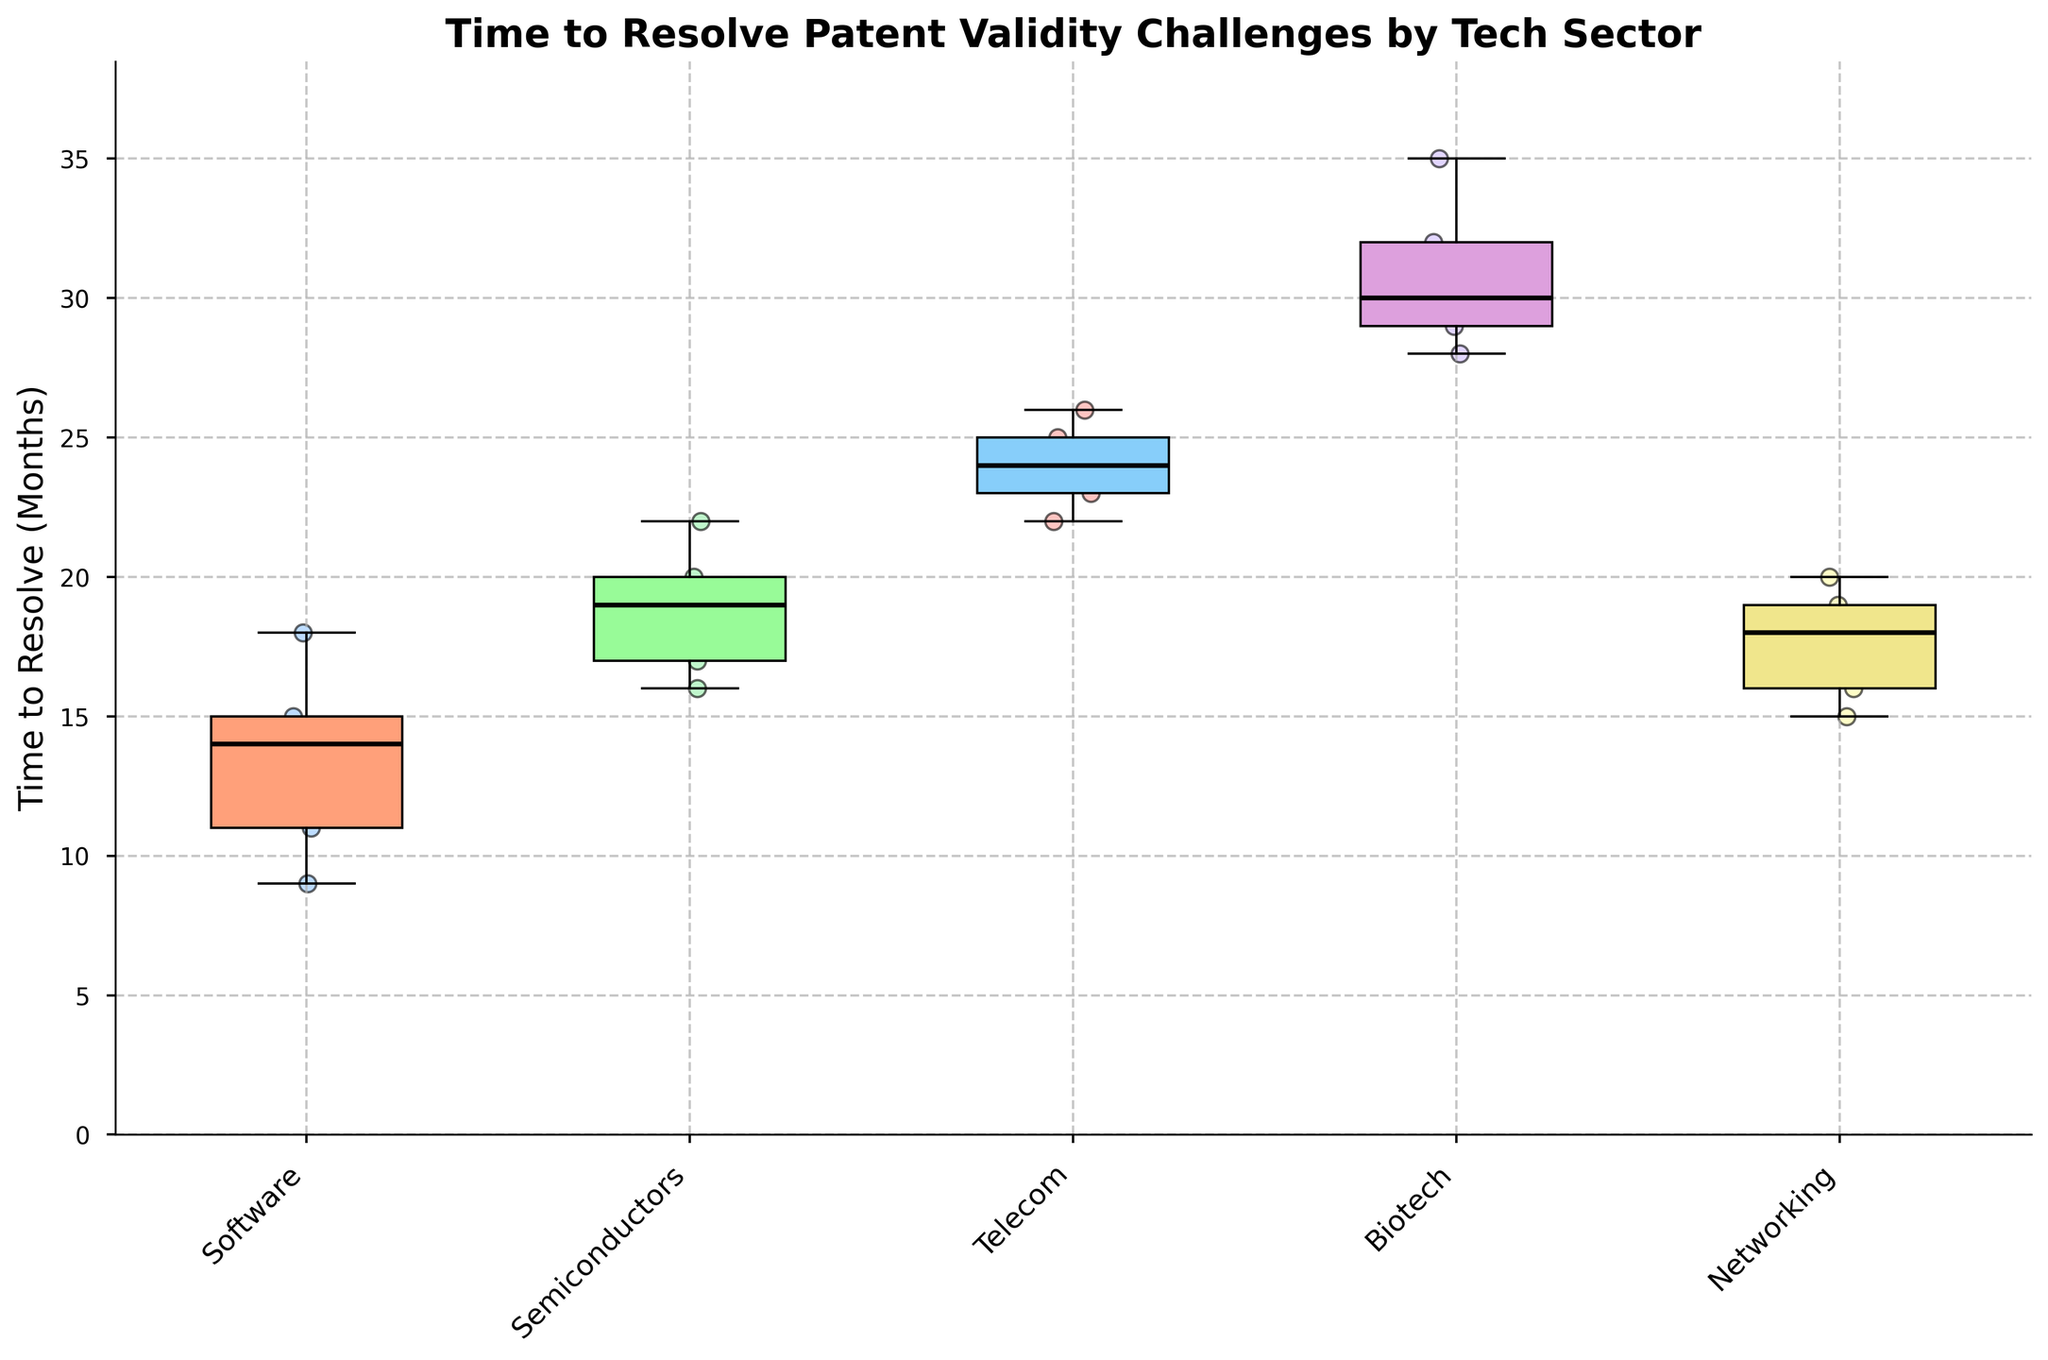What are the sectors included in the plot? The labels on the x-axis represent different tech sectors. By reading them, we can identify the sectors.
Answer: Software, Semiconductors, Telecom, Biotech, Networking What is the title of the box plot? The box plot's title is displayed at the top of the figure.
Answer: Time to Resolve Patent Validity Challenges by Tech Sector Which sector has the highest median time to resolve patent validity challenges? The sector with the highest median value will have the highest black line (the median indicator) within its box.
Answer: Biotech How does the time to resolve challenges compare between the Software and Networking sectors? Compare the medians of the boxes representing Software and Networking sectors. The Networking sector has a higher black line within its box.
Answer: Networking has a higher median time What is the range of time to resolve for the Telecom sector? The range can be found by looking at the minimum (bottom whisker) and maximum (top whisker) values of the Telecom box.
Answer: 22 to 26 months Which sector shows the most variability in the time to resolve patent validity challenges? Variability is indicated by the length of the boxes (interquartile range) and the whiskers. The Biotech sector has the longest box and whiskers.
Answer: Biotech What is the median time to resolve patent validity challenges in the Software sector? Locate the black line within the Software sector's box and look across to the y-axis.
Answer: 14 months Which two sectors have the closest median resolution times? Compare the positions of the black lines (medians) in each sector's box to identify the ones closest to each other.
Answer: Semiconductors and Networking What is the interquartile range (IQR) of the Biotech sector? The IQR is the range between the lower quartile (bottom line of the box) and the upper quartile (top line of the box) of the Biotech sector's box.
Answer: Approximately 3-4 months How do outliers affect the median calculation in the Software sector? Outliers do not affect the median as the median is the middle value and outliers lie beyond the whiskers of the box plot.
Answer: They do not affect the median 